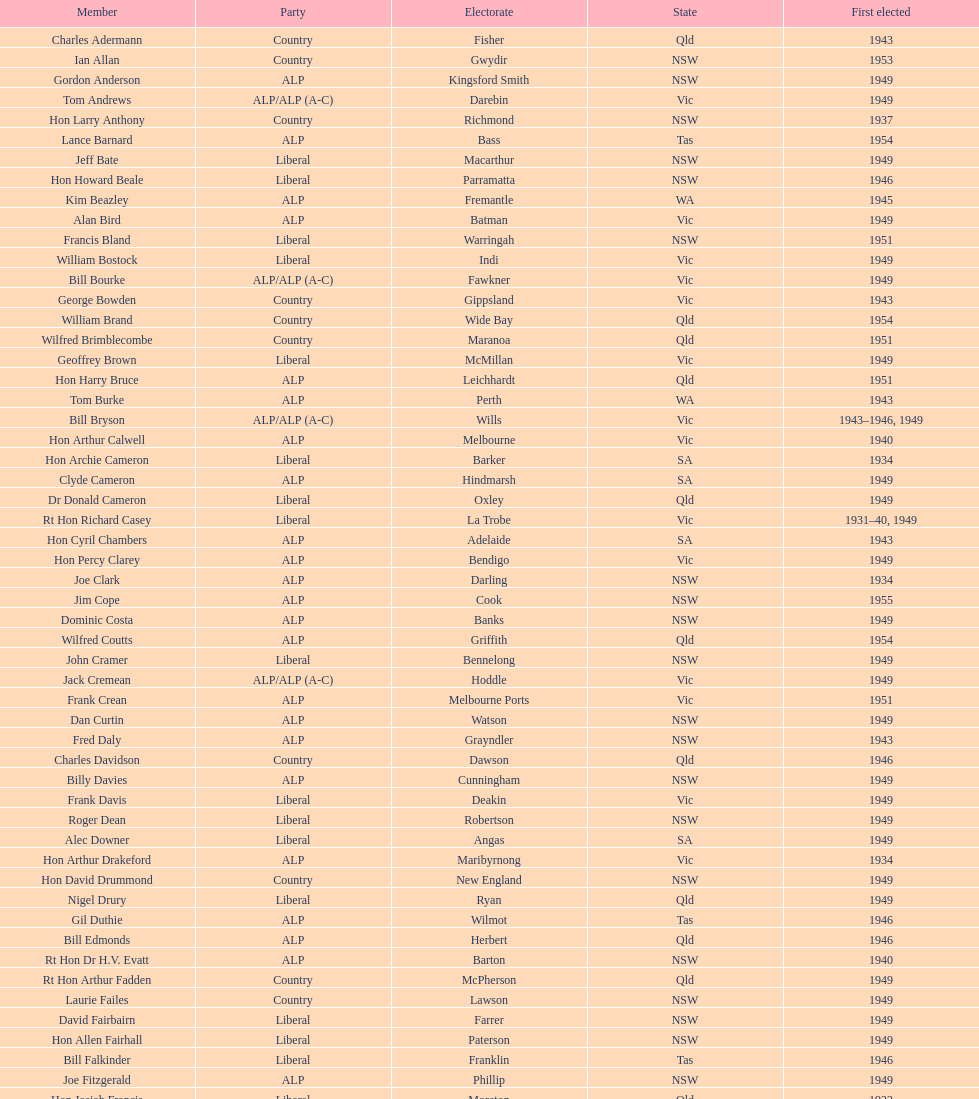Once tom burke got elected, what was the next year when another tom would be selected? 1937. 